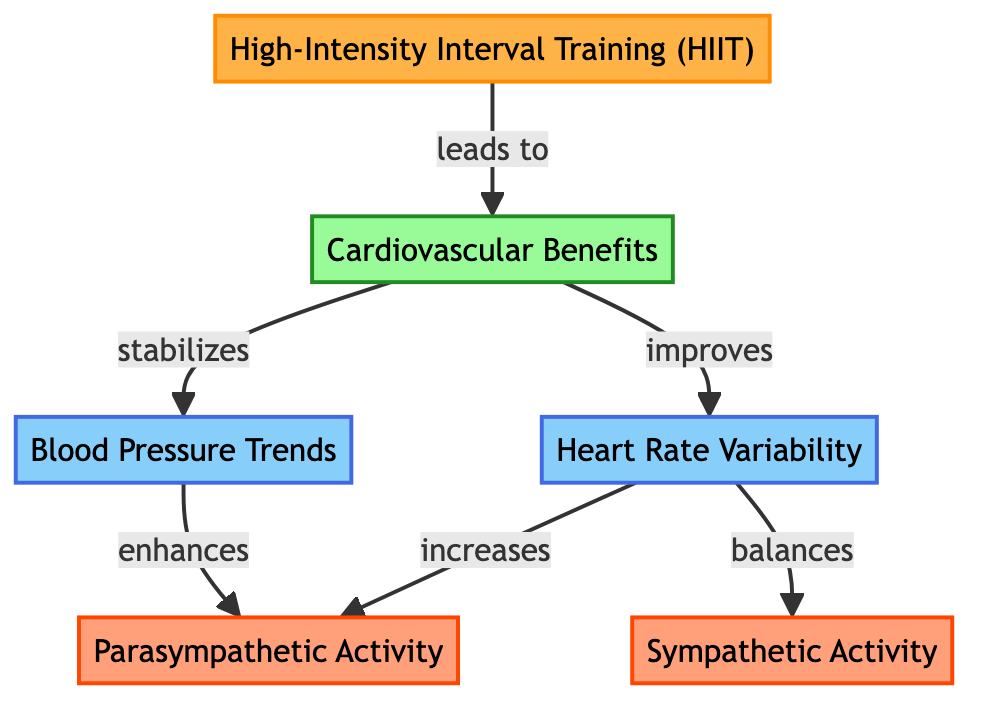What is the primary focus of the diagram? The diagram focuses on the cardiovascular benefits stemming from high-intensity interval training (HIIT). This is represented by the main node labeled "High-Intensity Interval Training (HIIT)," which is connected to the outcome node "Cardiovascular Benefits."
Answer: Cardiovascular Benefits How many indicator nodes are present in the diagram? The diagram contains two indicator nodes: "Heart Rate Variability" and "Blood Pressure Trends." By counting these nodes visually in the structure, you can confirm that they are identified as indicators of HIIT's benefits.
Answer: 2 What effect does HIIT have on heart rate variability according to the diagram? The diagram shows that HIIT leads to improved heart rate variability, as indicated by the direct connection between "Cardiovascular Benefits" and "Heart Rate Variability" with the word "improves" above the arrow connecting them.
Answer: Improves Which mechanism is connected to heart rate variability in the diagram? The diagram illustrates that heart rate variability is linked to two mechanisms: "Parasympathetic Activity" and "Sympathetic Activity." There are directed arrows pointing from "Heart Rate Variability" to both of these mechanisms, indicating this relationship.
Answer: Parasympathetic Activity and Sympathetic Activity What are the relationships between blood pressure trends and parasympathetic activity? The diagram indicates that blood pressure trends enhance parasympathetic activity, shown by the arrow between "Blood Pressure Trends" and "Parasympathetic Activity" along with the label "enhances." This suggests a direct influence.
Answer: Enhances What is the flow direction from "Heart Rate Variability" to "Sympathetic Activity"? The flow direction from "Heart Rate Variability" to "Sympathetic Activity" is characterized as a balancing effect. The arrow labeled "balances" indicates that there is a two-way relationship signifying equilibrium between these two indicators.
Answer: Balances Which node indicates the process of training in the diagram? The node that represents the process of training in the diagram is labeled "High-Intensity Interval Training (HIIT)," illustrated at the beginning point of the flow, indicating it is the starting mechanism for the outlined benefits.
Answer: High-Intensity Interval Training (HIIT) 